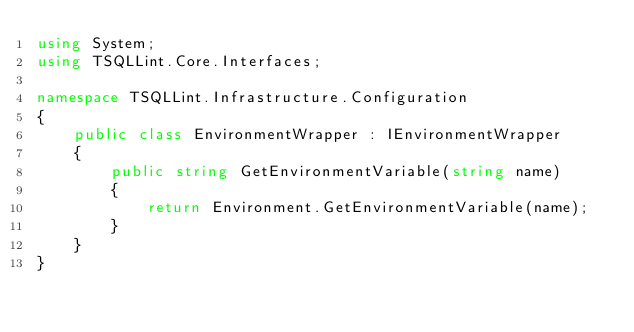<code> <loc_0><loc_0><loc_500><loc_500><_C#_>using System;
using TSQLLint.Core.Interfaces;

namespace TSQLLint.Infrastructure.Configuration
{
    public class EnvironmentWrapper : IEnvironmentWrapper
    {
        public string GetEnvironmentVariable(string name)
        {
            return Environment.GetEnvironmentVariable(name);
        }
    }
}
</code> 